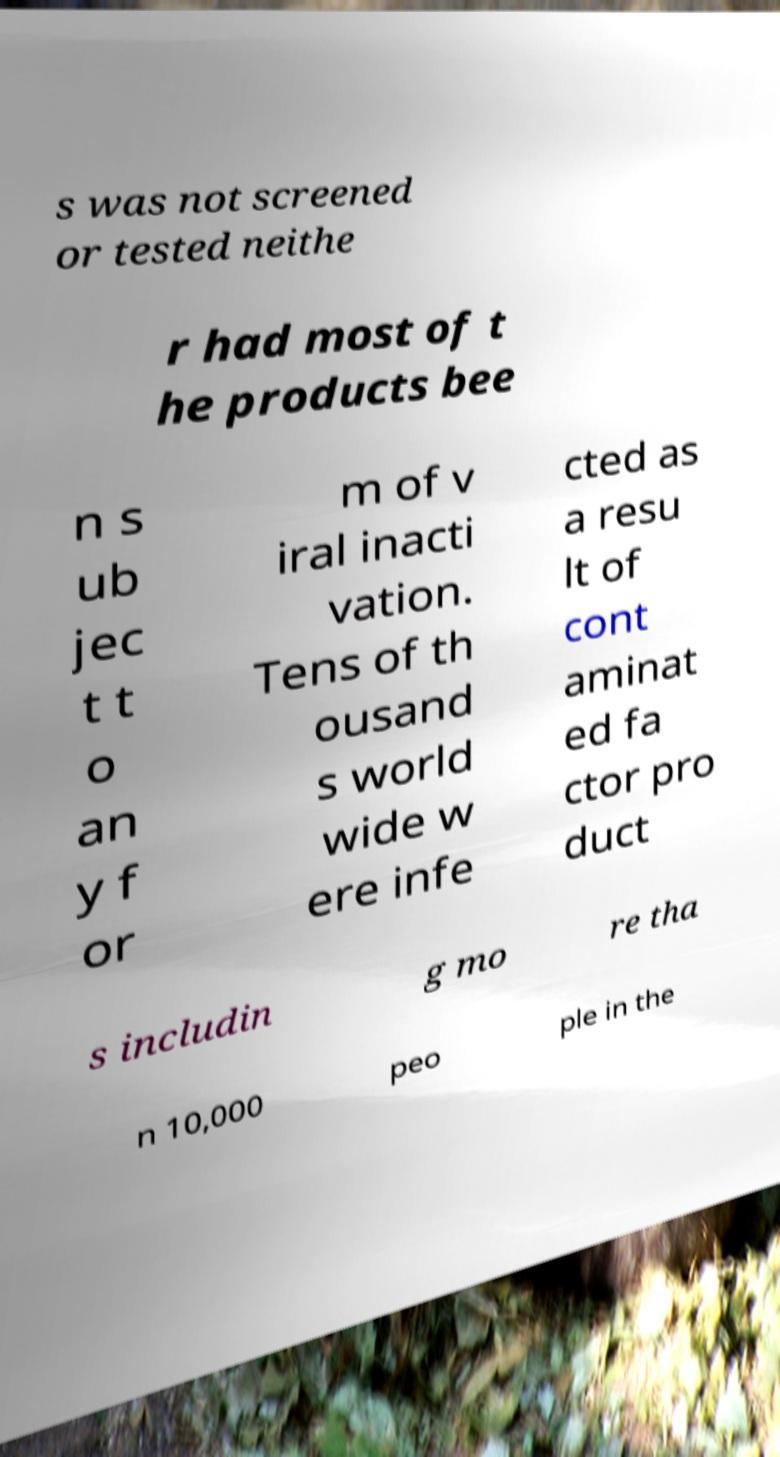I need the written content from this picture converted into text. Can you do that? s was not screened or tested neithe r had most of t he products bee n s ub jec t t o an y f or m of v iral inacti vation. Tens of th ousand s world wide w ere infe cted as a resu lt of cont aminat ed fa ctor pro duct s includin g mo re tha n 10,000 peo ple in the 